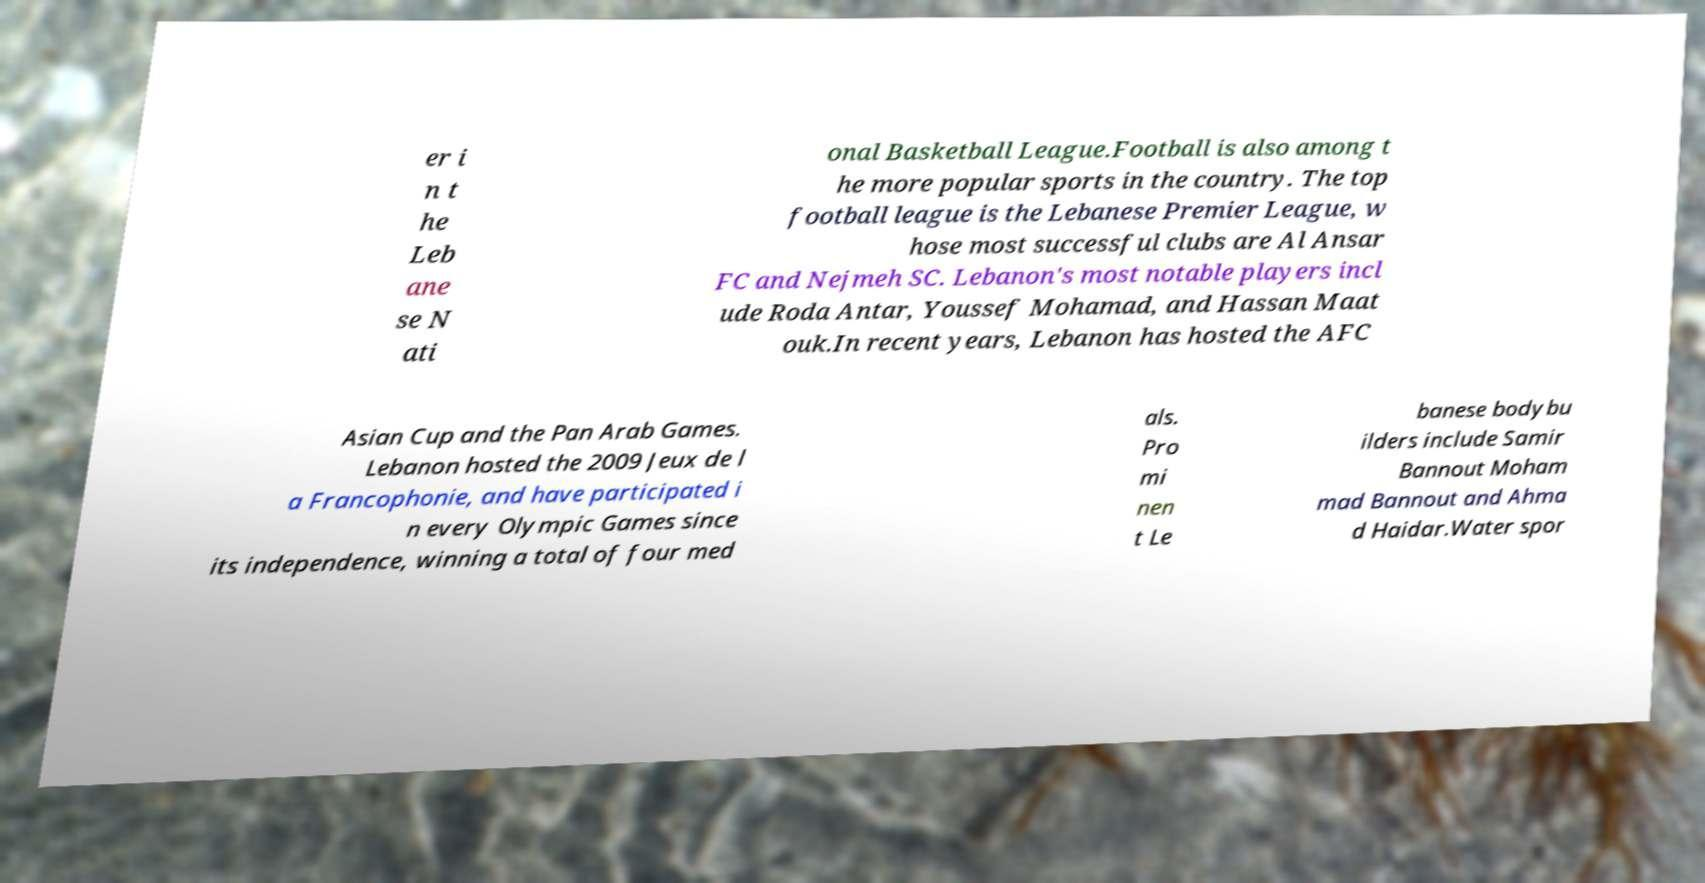I need the written content from this picture converted into text. Can you do that? er i n t he Leb ane se N ati onal Basketball League.Football is also among t he more popular sports in the country. The top football league is the Lebanese Premier League, w hose most successful clubs are Al Ansar FC and Nejmeh SC. Lebanon's most notable players incl ude Roda Antar, Youssef Mohamad, and Hassan Maat ouk.In recent years, Lebanon has hosted the AFC Asian Cup and the Pan Arab Games. Lebanon hosted the 2009 Jeux de l a Francophonie, and have participated i n every Olympic Games since its independence, winning a total of four med als. Pro mi nen t Le banese bodybu ilders include Samir Bannout Moham mad Bannout and Ahma d Haidar.Water spor 